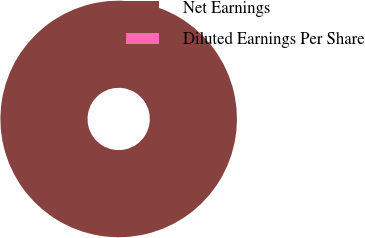<chart> <loc_0><loc_0><loc_500><loc_500><pie_chart><fcel>Net Earnings<fcel>Diluted Earnings Per Share<nl><fcel>100.0%<fcel>0.0%<nl></chart> 